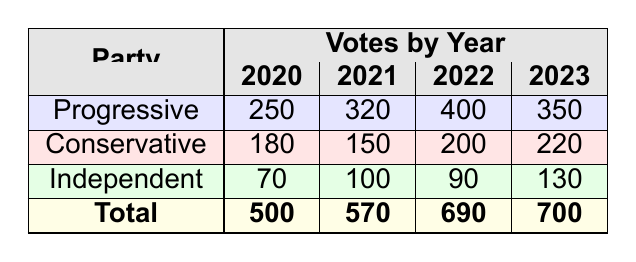What was the total number of votes in 2022? The table shows the total votes in 2022 as 690, which is marked in the "Total" row under the "2022" column.
Answer: 690 Which party received the least votes in 2021? In 2021, the votes for each party were Progressive: 320, Conservative: 150, and Independent: 100. The least votes were for the Conservative party with 150 votes.
Answer: Conservative What is the difference in votes for the Progressive party between 2020 and 2022? The votes for the Progressive party in 2020 were 250, and in 2022, they were 400. The difference is calculated as 400 - 250 = 150.
Answer: 150 Did the Independent party gain votes from 2020 to 2023? The votes for the Independent party were 70 in 2020 and 130 in 2023. Since 130 is greater than 70, it confirms a gain in votes.
Answer: Yes What was the average number of votes for the Conservative party over the four years? The Conservative party had the following votes: 180 (2020), 150 (2021), 200 (2022), and 220 (2023). The sum is 750, and dividing by 4 gives an average of 750/4 = 187.5.
Answer: 187.5 How did the total number of votes change from 2020 to 2023? The total votes in 2020 were 500, and in 2023 they were 700. The change is calculated as 700 - 500 = 200. Thus, the total number of votes increased by 200.
Answer: Increased by 200 Which year had the highest total votes? The total votes for each year are as follows: 2020: 500, 2021: 570, 2022: 690, 2023: 700. The highest total is in 2023 with 700 votes.
Answer: 2023 Was there a decline in votes for the Independent party from 2021 to 2022? The Independent party received 100 votes in 2021 and 90 votes in 2022. Since 90 is lower than 100, there was a decline.
Answer: Yes How many more votes did the Progressive party receive than the Independent party in 2023? In 2023, the Progressive party had 350 votes while the Independent party had 130 votes. The difference is calculated as 350 - 130 = 220.
Answer: 220 